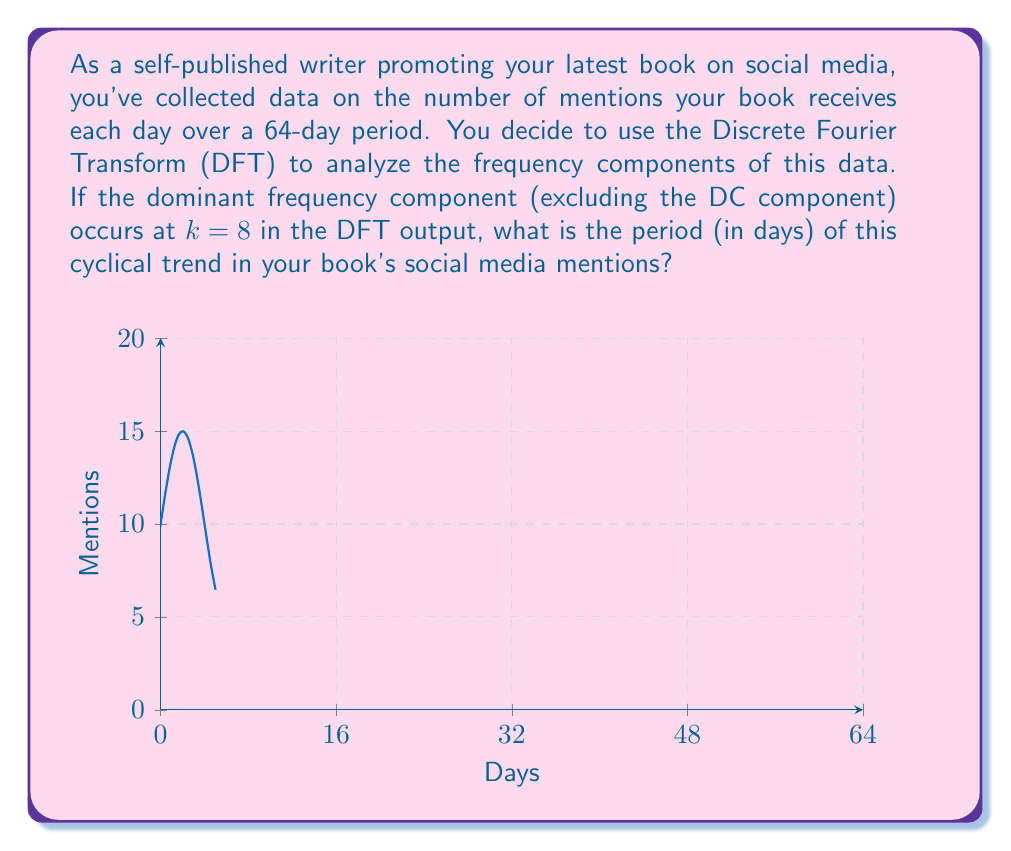Solve this math problem. Let's approach this step-by-step:

1) The Discrete Fourier Transform (DFT) of a signal of length N converts it into frequency domain, where k represents the frequency bin.

2) The relationship between the frequency bin k and the actual frequency f is given by:

   $f = \frac{k}{N} \cdot f_s$

   where $f_s$ is the sampling frequency.

3) In this case, we have:
   - N = 64 (64-day period)
   - k = 8 (given in the question)
   - $f_s = 1$ day$^{-1}$ (as we have one sample per day)

4) Plugging these values into the formula:

   $f = \frac{8}{64} \cdot 1 \text{ day}^{-1} = \frac{1}{8} \text{ day}^{-1}$

5) The period T is the inverse of the frequency:

   $T = \frac{1}{f} = \frac{1}{\frac{1}{8} \text{ day}^{-1}} = 8 \text{ days}$

Therefore, the cyclical trend in your book's social media mentions has a period of 8 days.
Answer: 8 days 